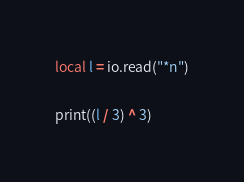<code> <loc_0><loc_0><loc_500><loc_500><_Lua_>local l = io.read("*n")

print((l / 3) ^ 3)</code> 